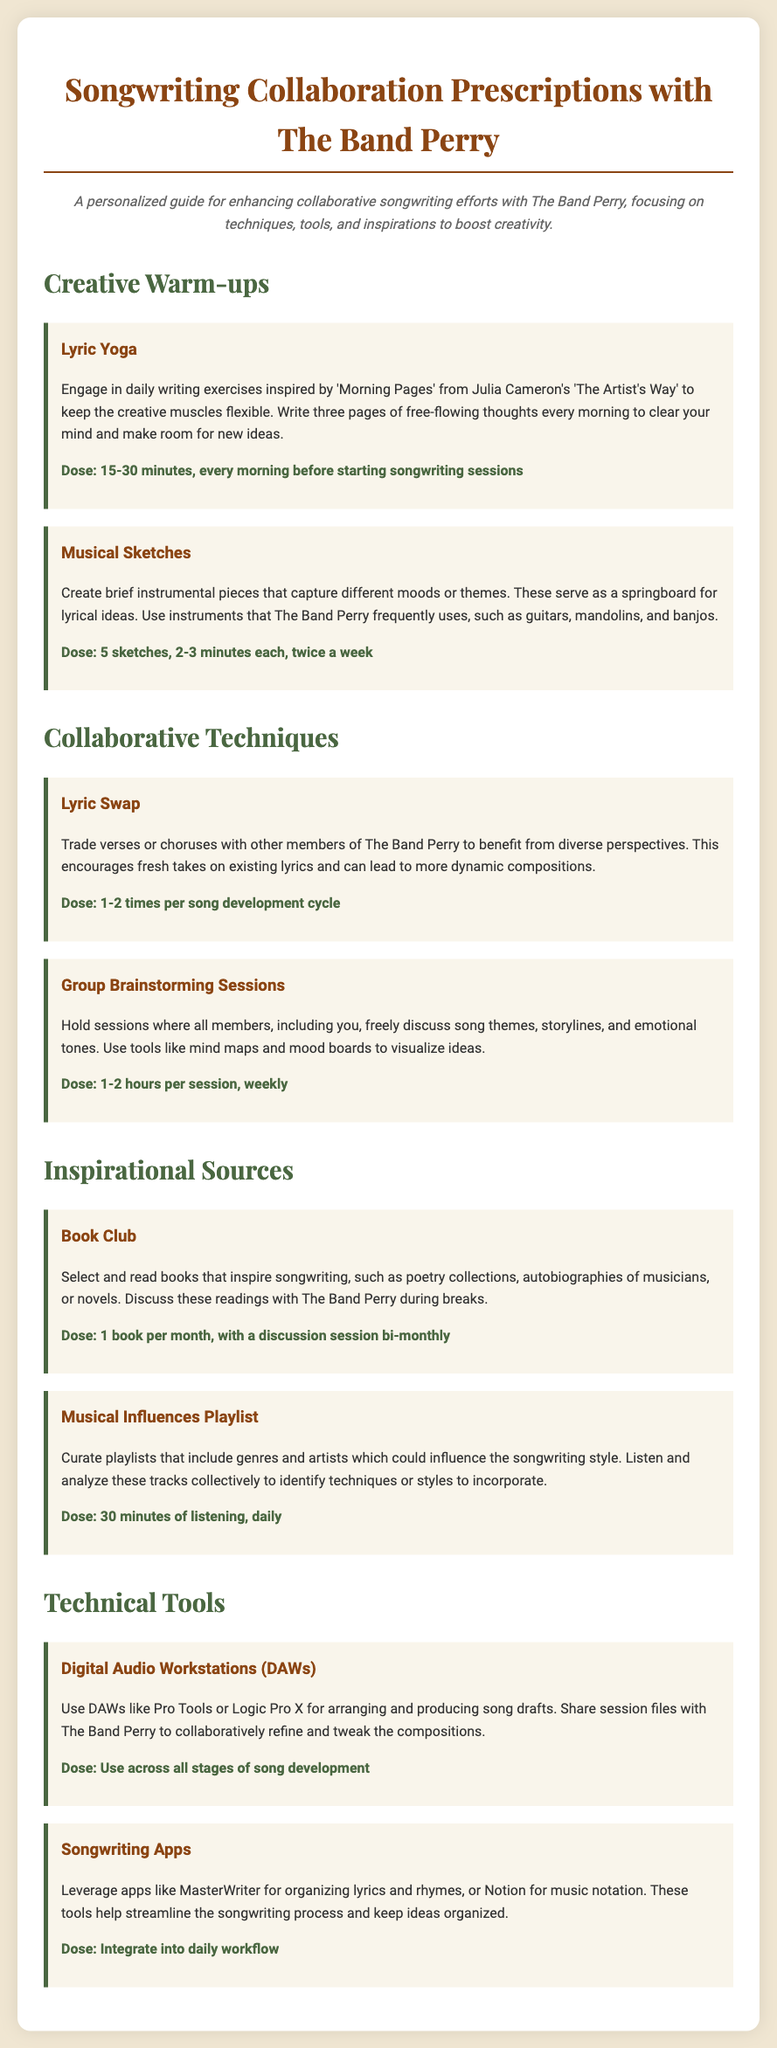What is the title of the document? The title of the document is indicated at the top of the HTML structure.
Answer: Songwriting Collaboration Prescriptions with The Band Perry How long should the Lyric Yoga warm-up last? The document specifies the time required for the Lyric Yoga exercise.
Answer: 15-30 minutes What type of sessions does the document recommend for brainstorming? The document describes a specific kind of session for generating ideas collaboratively.
Answer: Group Brainstorming Sessions How often should the Musical Influences Playlist be listened to? The document clearly states the frequency for engaging with the playlist.
Answer: Daily What is the recommended dose for the Book Club activity? The document details the frequency and quantity for participating in the Book Club.
Answer: 1 book per month Why are musical sketches created? The purpose of musical sketches is explained in the context of songwriting collaboration.
Answer: To capture different moods or themes How many sketches should be created each week? The document specifies the number of sketches to be completed weekly.
Answer: 10 sketches Which tool is mentioned for organizing lyrics? The document lists specific apps to streamline the songwriting process.
Answer: MasterWriter 